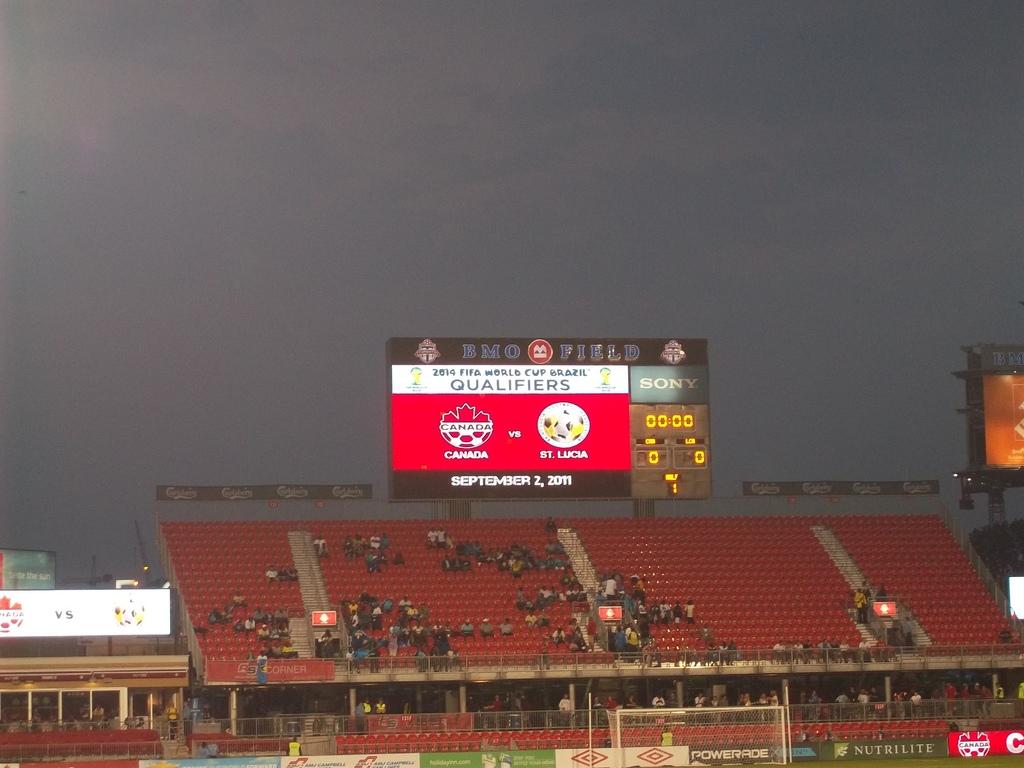Who is playing canada at the game?
Keep it short and to the point. St. lucia. What is the date?
Your answer should be very brief. September 2, 2011. 